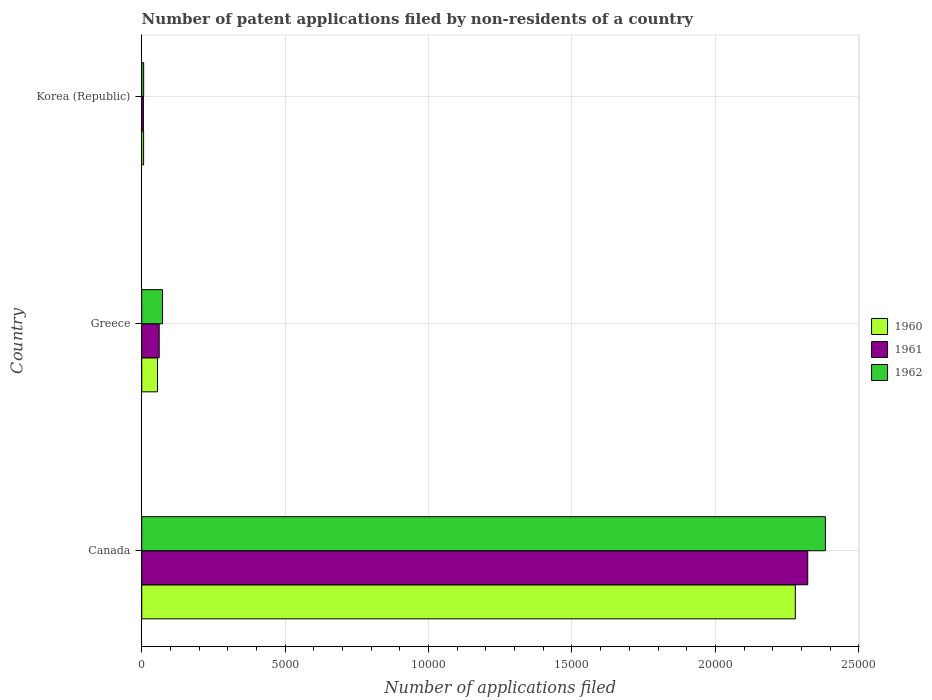How many bars are there on the 2nd tick from the bottom?
Ensure brevity in your answer.  3. In how many cases, is the number of bars for a given country not equal to the number of legend labels?
Give a very brief answer. 0. What is the number of applications filed in 1962 in Canada?
Your answer should be very brief. 2.38e+04. Across all countries, what is the maximum number of applications filed in 1960?
Your answer should be very brief. 2.28e+04. Across all countries, what is the minimum number of applications filed in 1960?
Keep it short and to the point. 66. What is the total number of applications filed in 1962 in the graph?
Your answer should be very brief. 2.46e+04. What is the difference between the number of applications filed in 1962 in Canada and that in Korea (Republic)?
Give a very brief answer. 2.38e+04. What is the difference between the number of applications filed in 1961 in Greece and the number of applications filed in 1960 in Korea (Republic)?
Your answer should be very brief. 543. What is the average number of applications filed in 1961 per country?
Your answer should be very brief. 7962. What is the difference between the number of applications filed in 1962 and number of applications filed in 1960 in Greece?
Your answer should be compact. 175. In how many countries, is the number of applications filed in 1961 greater than 5000 ?
Keep it short and to the point. 1. What is the ratio of the number of applications filed in 1962 in Greece to that in Korea (Republic)?
Provide a short and direct response. 10.68. Is the number of applications filed in 1962 in Canada less than that in Greece?
Provide a succinct answer. No. Is the difference between the number of applications filed in 1962 in Canada and Korea (Republic) greater than the difference between the number of applications filed in 1960 in Canada and Korea (Republic)?
Provide a succinct answer. Yes. What is the difference between the highest and the second highest number of applications filed in 1960?
Offer a terse response. 2.22e+04. What is the difference between the highest and the lowest number of applications filed in 1962?
Your response must be concise. 2.38e+04. What does the 2nd bar from the bottom in Canada represents?
Make the answer very short. 1961. Is it the case that in every country, the sum of the number of applications filed in 1960 and number of applications filed in 1962 is greater than the number of applications filed in 1961?
Give a very brief answer. Yes. How many bars are there?
Ensure brevity in your answer.  9. How many countries are there in the graph?
Make the answer very short. 3. What is the difference between two consecutive major ticks on the X-axis?
Provide a short and direct response. 5000. How are the legend labels stacked?
Offer a terse response. Vertical. What is the title of the graph?
Offer a terse response. Number of patent applications filed by non-residents of a country. Does "1979" appear as one of the legend labels in the graph?
Give a very brief answer. No. What is the label or title of the X-axis?
Keep it short and to the point. Number of applications filed. What is the Number of applications filed of 1960 in Canada?
Keep it short and to the point. 2.28e+04. What is the Number of applications filed in 1961 in Canada?
Offer a terse response. 2.32e+04. What is the Number of applications filed of 1962 in Canada?
Offer a very short reply. 2.38e+04. What is the Number of applications filed of 1960 in Greece?
Offer a terse response. 551. What is the Number of applications filed of 1961 in Greece?
Keep it short and to the point. 609. What is the Number of applications filed of 1962 in Greece?
Your answer should be very brief. 726. What is the Number of applications filed of 1960 in Korea (Republic)?
Your answer should be very brief. 66. What is the Number of applications filed of 1961 in Korea (Republic)?
Provide a succinct answer. 58. What is the Number of applications filed of 1962 in Korea (Republic)?
Offer a very short reply. 68. Across all countries, what is the maximum Number of applications filed in 1960?
Ensure brevity in your answer.  2.28e+04. Across all countries, what is the maximum Number of applications filed of 1961?
Provide a short and direct response. 2.32e+04. Across all countries, what is the maximum Number of applications filed in 1962?
Provide a succinct answer. 2.38e+04. Across all countries, what is the minimum Number of applications filed of 1961?
Your answer should be compact. 58. What is the total Number of applications filed of 1960 in the graph?
Your answer should be compact. 2.34e+04. What is the total Number of applications filed of 1961 in the graph?
Keep it short and to the point. 2.39e+04. What is the total Number of applications filed in 1962 in the graph?
Your answer should be compact. 2.46e+04. What is the difference between the Number of applications filed in 1960 in Canada and that in Greece?
Ensure brevity in your answer.  2.22e+04. What is the difference between the Number of applications filed of 1961 in Canada and that in Greece?
Your answer should be compact. 2.26e+04. What is the difference between the Number of applications filed of 1962 in Canada and that in Greece?
Make the answer very short. 2.31e+04. What is the difference between the Number of applications filed in 1960 in Canada and that in Korea (Republic)?
Keep it short and to the point. 2.27e+04. What is the difference between the Number of applications filed in 1961 in Canada and that in Korea (Republic)?
Ensure brevity in your answer.  2.32e+04. What is the difference between the Number of applications filed in 1962 in Canada and that in Korea (Republic)?
Offer a very short reply. 2.38e+04. What is the difference between the Number of applications filed of 1960 in Greece and that in Korea (Republic)?
Offer a very short reply. 485. What is the difference between the Number of applications filed of 1961 in Greece and that in Korea (Republic)?
Your answer should be compact. 551. What is the difference between the Number of applications filed of 1962 in Greece and that in Korea (Republic)?
Your answer should be very brief. 658. What is the difference between the Number of applications filed of 1960 in Canada and the Number of applications filed of 1961 in Greece?
Provide a short and direct response. 2.22e+04. What is the difference between the Number of applications filed in 1960 in Canada and the Number of applications filed in 1962 in Greece?
Your response must be concise. 2.21e+04. What is the difference between the Number of applications filed of 1961 in Canada and the Number of applications filed of 1962 in Greece?
Your answer should be compact. 2.25e+04. What is the difference between the Number of applications filed of 1960 in Canada and the Number of applications filed of 1961 in Korea (Republic)?
Offer a terse response. 2.27e+04. What is the difference between the Number of applications filed in 1960 in Canada and the Number of applications filed in 1962 in Korea (Republic)?
Make the answer very short. 2.27e+04. What is the difference between the Number of applications filed in 1961 in Canada and the Number of applications filed in 1962 in Korea (Republic)?
Give a very brief answer. 2.32e+04. What is the difference between the Number of applications filed in 1960 in Greece and the Number of applications filed in 1961 in Korea (Republic)?
Your answer should be very brief. 493. What is the difference between the Number of applications filed of 1960 in Greece and the Number of applications filed of 1962 in Korea (Republic)?
Give a very brief answer. 483. What is the difference between the Number of applications filed of 1961 in Greece and the Number of applications filed of 1962 in Korea (Republic)?
Provide a succinct answer. 541. What is the average Number of applications filed in 1960 per country?
Your response must be concise. 7801. What is the average Number of applications filed in 1961 per country?
Provide a succinct answer. 7962. What is the average Number of applications filed in 1962 per country?
Ensure brevity in your answer.  8209.33. What is the difference between the Number of applications filed in 1960 and Number of applications filed in 1961 in Canada?
Give a very brief answer. -433. What is the difference between the Number of applications filed in 1960 and Number of applications filed in 1962 in Canada?
Offer a very short reply. -1048. What is the difference between the Number of applications filed in 1961 and Number of applications filed in 1962 in Canada?
Ensure brevity in your answer.  -615. What is the difference between the Number of applications filed of 1960 and Number of applications filed of 1961 in Greece?
Your answer should be very brief. -58. What is the difference between the Number of applications filed in 1960 and Number of applications filed in 1962 in Greece?
Provide a succinct answer. -175. What is the difference between the Number of applications filed in 1961 and Number of applications filed in 1962 in Greece?
Your answer should be compact. -117. What is the difference between the Number of applications filed of 1960 and Number of applications filed of 1961 in Korea (Republic)?
Keep it short and to the point. 8. What is the difference between the Number of applications filed of 1960 and Number of applications filed of 1962 in Korea (Republic)?
Ensure brevity in your answer.  -2. What is the ratio of the Number of applications filed in 1960 in Canada to that in Greece?
Your answer should be compact. 41.35. What is the ratio of the Number of applications filed of 1961 in Canada to that in Greece?
Make the answer very short. 38.13. What is the ratio of the Number of applications filed of 1962 in Canada to that in Greece?
Your answer should be compact. 32.83. What is the ratio of the Number of applications filed in 1960 in Canada to that in Korea (Republic)?
Make the answer very short. 345.24. What is the ratio of the Number of applications filed in 1961 in Canada to that in Korea (Republic)?
Give a very brief answer. 400.33. What is the ratio of the Number of applications filed of 1962 in Canada to that in Korea (Republic)?
Your response must be concise. 350.5. What is the ratio of the Number of applications filed in 1960 in Greece to that in Korea (Republic)?
Your answer should be compact. 8.35. What is the ratio of the Number of applications filed in 1961 in Greece to that in Korea (Republic)?
Make the answer very short. 10.5. What is the ratio of the Number of applications filed in 1962 in Greece to that in Korea (Republic)?
Your answer should be very brief. 10.68. What is the difference between the highest and the second highest Number of applications filed of 1960?
Your response must be concise. 2.22e+04. What is the difference between the highest and the second highest Number of applications filed in 1961?
Offer a terse response. 2.26e+04. What is the difference between the highest and the second highest Number of applications filed in 1962?
Offer a very short reply. 2.31e+04. What is the difference between the highest and the lowest Number of applications filed in 1960?
Your response must be concise. 2.27e+04. What is the difference between the highest and the lowest Number of applications filed of 1961?
Provide a short and direct response. 2.32e+04. What is the difference between the highest and the lowest Number of applications filed in 1962?
Offer a very short reply. 2.38e+04. 